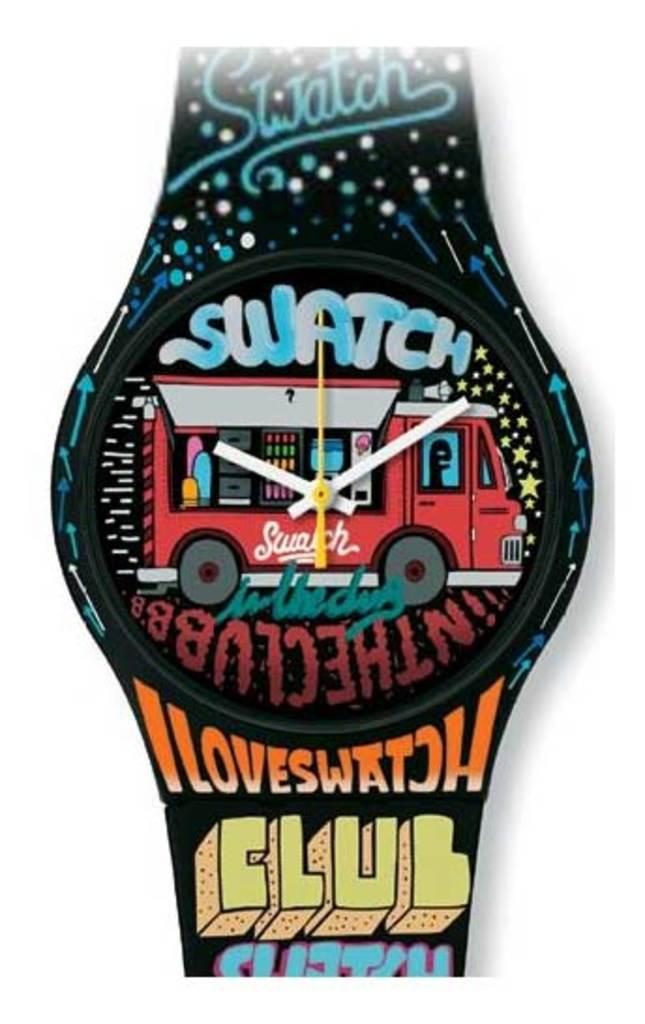<image>
Relay a brief, clear account of the picture shown. A multi colored Swatch brand wristwatch with different words all over the band. 